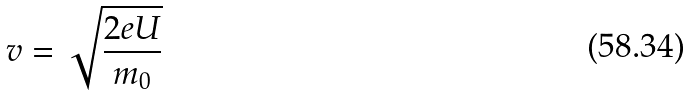Convert formula to latex. <formula><loc_0><loc_0><loc_500><loc_500>v = \sqrt { \frac { 2 e U } { m _ { 0 } } }</formula> 